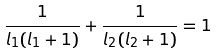<formula> <loc_0><loc_0><loc_500><loc_500>\frac { 1 } { l _ { 1 } ( l _ { 1 } + 1 ) } + \frac { 1 } { l _ { 2 } ( l _ { 2 } + 1 ) } = 1</formula> 